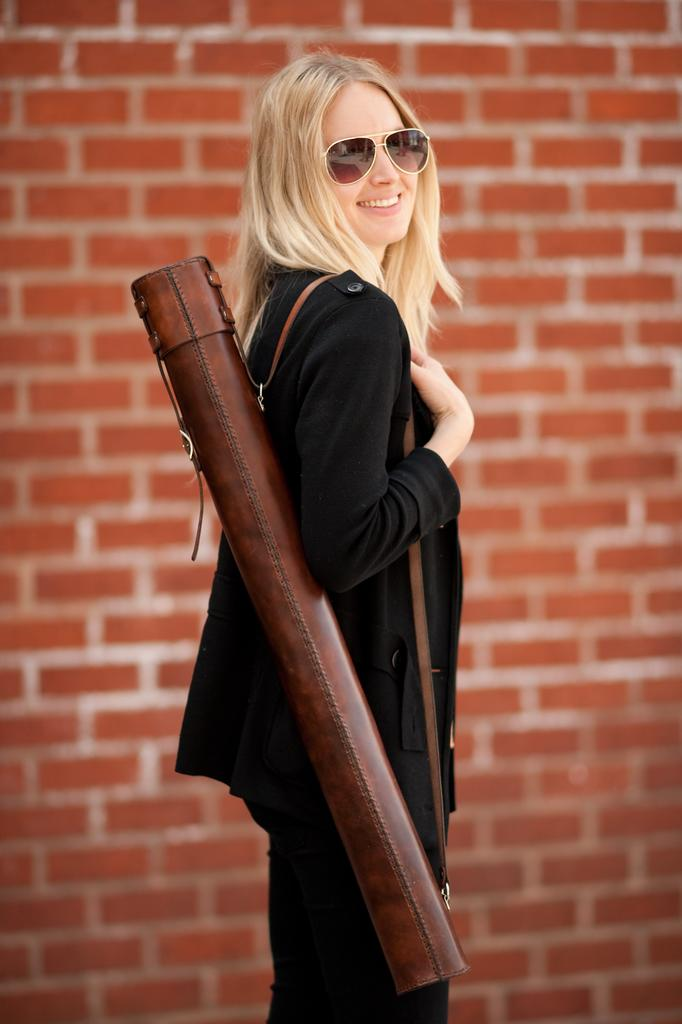What is the appearance of the woman in the image? There is a beautiful woman in the image. What is the woman doing in the image? The woman is standing. What color is the dress the woman is wearing? The woman is wearing a black dress. What accessory is the woman wearing on her face? The woman is wearing goggles. What can be seen behind the woman in the image? There is a brick wall behind the woman. How many beans are visible on the woman's legs in the image? There are no beans visible on the woman's legs in the image. What type of humor is the woman displaying in the image? There is no indication of humor in the image; the woman is simply standing with goggles on. 